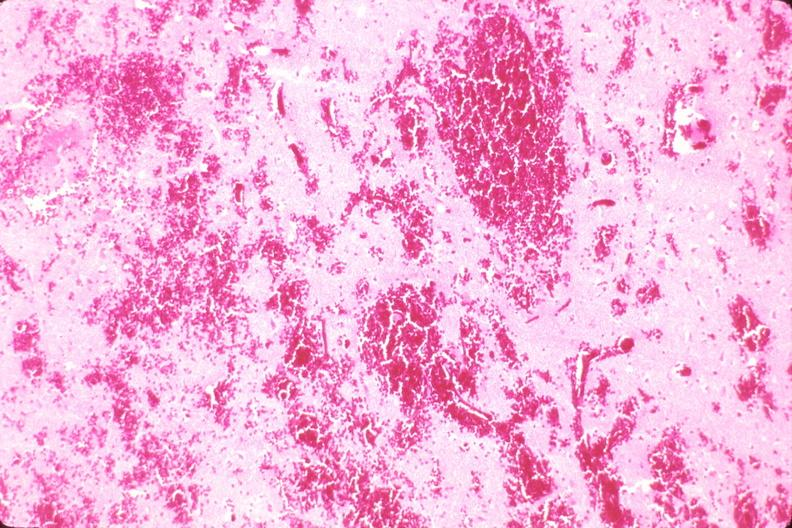why does this image show brain, intraparenchymal hemorrhage?
Answer the question using a single word or phrase. Due to ruptured aneurysm 